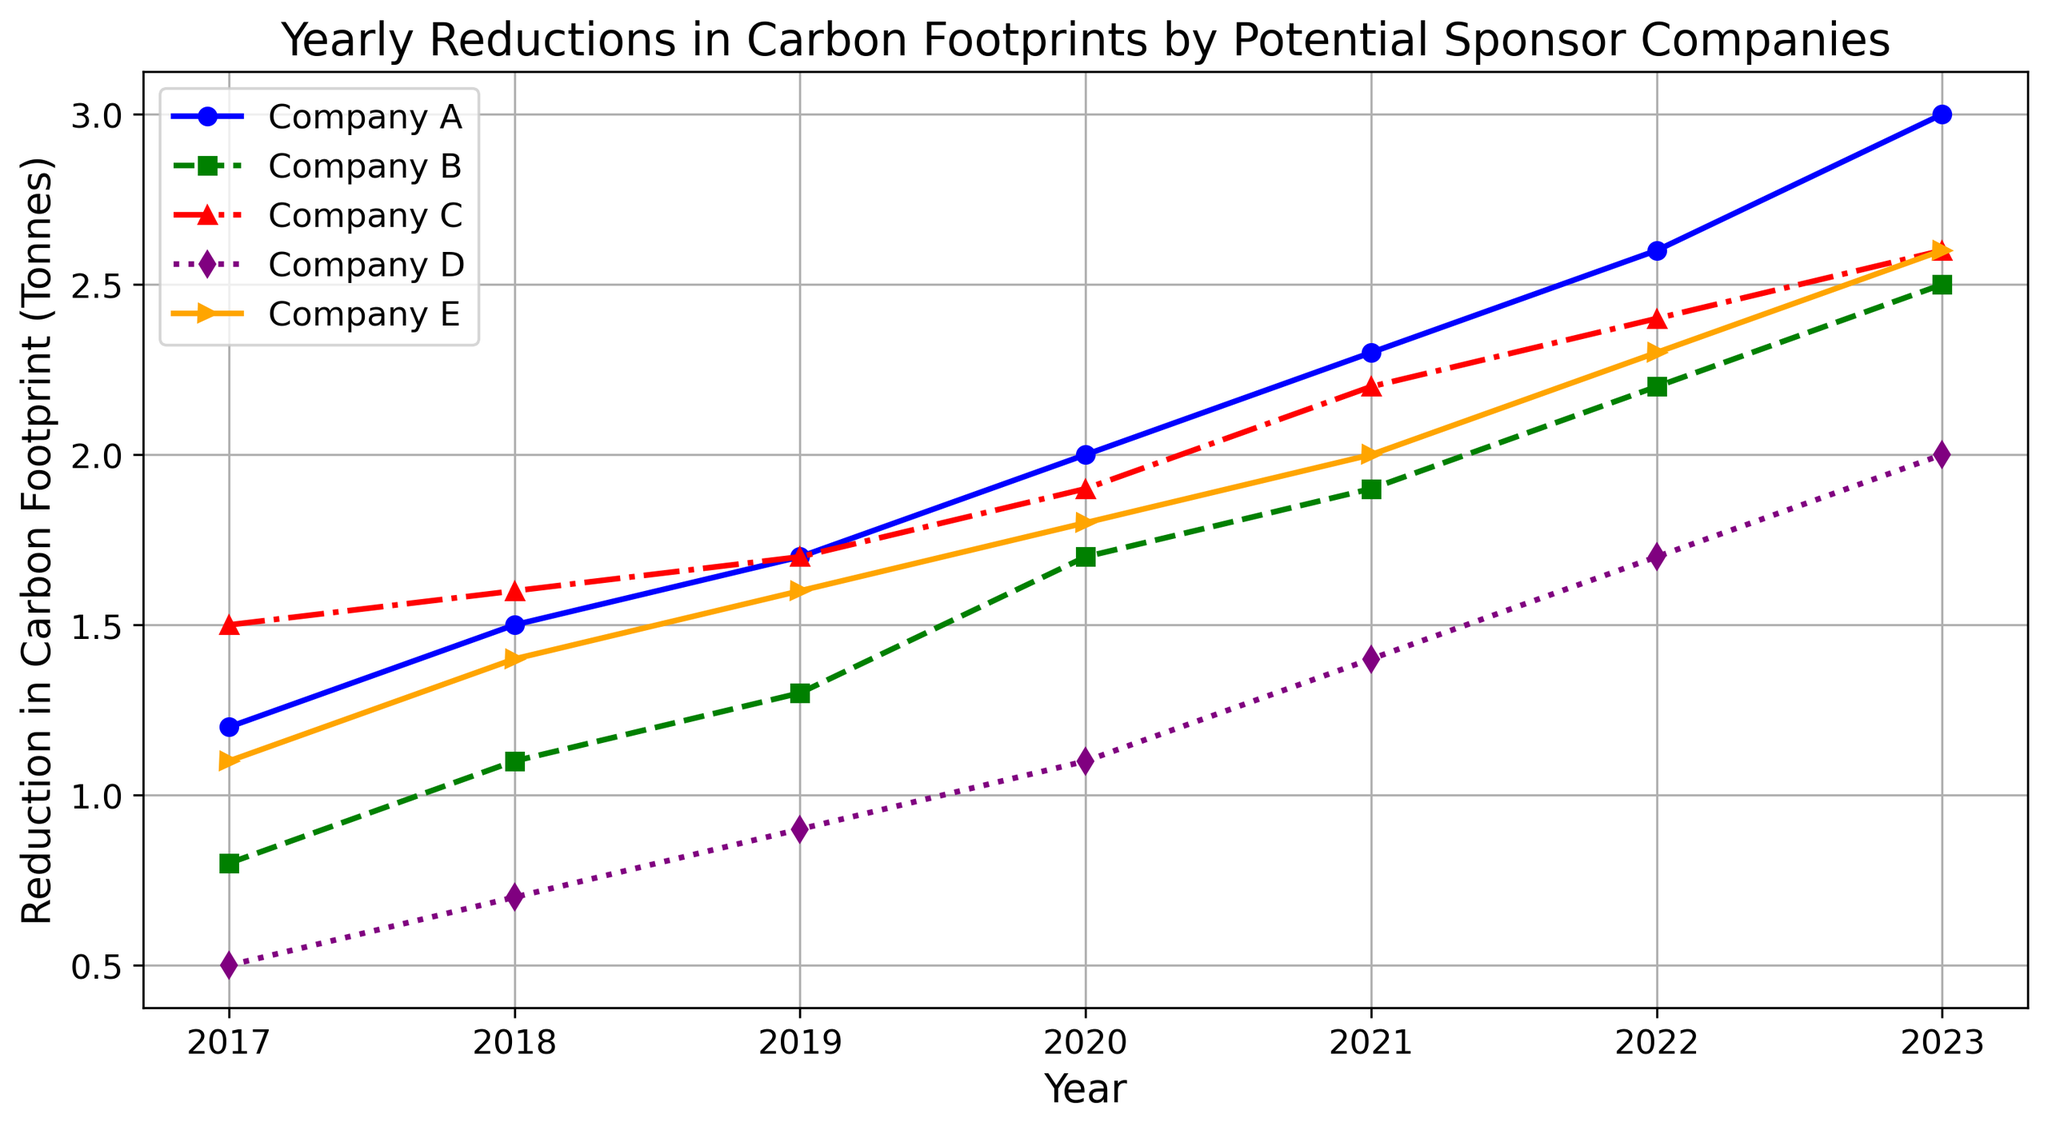what color represents Company C in the figure? The legend in the figure shows Company C is represented by the color red.
Answer: red Which company had the highest reduction in carbon footprints in 2023? At the 2023 mark on the x-axis, the point for Company A is the highest on the y-axis among all companies.
Answer: Company A How much did Company E's reduction in 2023 differ from its reduction in 2017? Company E's reduction in 2023 is 2.6 and in 2017 it was 1.1. The difference is calculated as 2.6 - 1.1.
Answer: 1.5 What is the average reduction in carbon footprints for Company A from 2017 to 2023? Add Company A's reductions from each year and divide by the number of years: (1.2 + 1.5 + 1.7 + 2.0 + 2.3 + 2.6 + 3.0) / 7.
Answer: 2.04 Which company showed the least consistent yearly increase in reduction from 2017 to 2023? The line for Company D is the most erratic or inconsistent, shown by varying slopes between years.
Answer: Company D In what year did Company D first achieve a reduction of more than 1.0 tonnes? According to the line for Company D, the reduction surpasses 1.0 in 2020.
Answer: 2020 How does the reduction in carbon footprints of Company B compare to Company E in 2021? At 2021 on the x-axis, the point for Company B (1.9) is lower than that of Company E (2.0).
Answer: Company E had a higher reduction Which company had the greatest increase in reduction from 2021 to 2023? For each company, subtract the 2021 reduction from the 2023 reduction: 
Company A: 3.0 - 2.3 = 0.7
Company B: 2.5 - 1.9 = 0.6
Company C: 2.6 - 2.2 = 0.4
Company D: 2.0 - 1.4 = 0.6
Company E: 2.6 - 2.0 = 0.6
Company A has the greatest increase.
Answer: Company A 